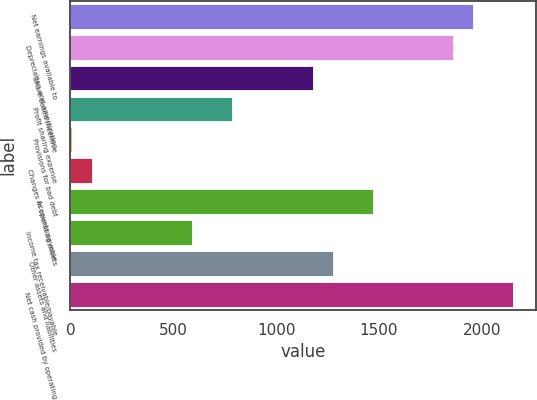Convert chart to OTSL. <chart><loc_0><loc_0><loc_500><loc_500><bar_chart><fcel>Net earnings available to<fcel>Depreciation and amortization<fcel>Share-based incentive<fcel>Profit sharing expense<fcel>Provisions for bad debt<fcel>Changes in operating assets<fcel>Accounts payable<fcel>Income tax receivable/payable<fcel>Other assets and liabilities<fcel>Net cash provided by operating<nl><fcel>1958.4<fcel>1860.77<fcel>1177.36<fcel>786.84<fcel>5.8<fcel>103.43<fcel>1470.25<fcel>591.58<fcel>1274.99<fcel>2153.66<nl></chart> 